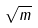Convert formula to latex. <formula><loc_0><loc_0><loc_500><loc_500>\sqrt { m }</formula> 